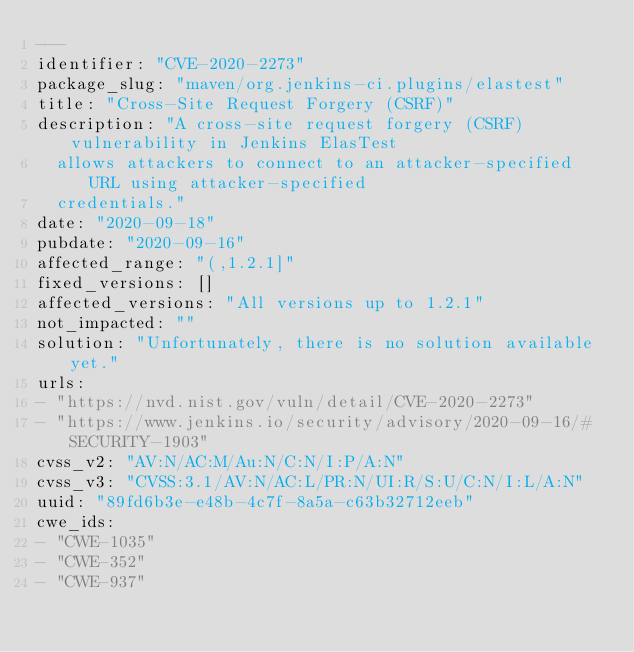Convert code to text. <code><loc_0><loc_0><loc_500><loc_500><_YAML_>---
identifier: "CVE-2020-2273"
package_slug: "maven/org.jenkins-ci.plugins/elastest"
title: "Cross-Site Request Forgery (CSRF)"
description: "A cross-site request forgery (CSRF) vulnerability in Jenkins ElasTest
  allows attackers to connect to an attacker-specified URL using attacker-specified
  credentials."
date: "2020-09-18"
pubdate: "2020-09-16"
affected_range: "(,1.2.1]"
fixed_versions: []
affected_versions: "All versions up to 1.2.1"
not_impacted: ""
solution: "Unfortunately, there is no solution available yet."
urls:
- "https://nvd.nist.gov/vuln/detail/CVE-2020-2273"
- "https://www.jenkins.io/security/advisory/2020-09-16/#SECURITY-1903"
cvss_v2: "AV:N/AC:M/Au:N/C:N/I:P/A:N"
cvss_v3: "CVSS:3.1/AV:N/AC:L/PR:N/UI:R/S:U/C:N/I:L/A:N"
uuid: "89fd6b3e-e48b-4c7f-8a5a-c63b32712eeb"
cwe_ids:
- "CWE-1035"
- "CWE-352"
- "CWE-937"
</code> 